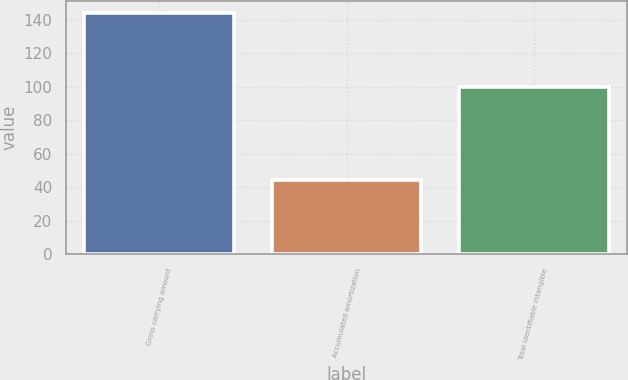<chart> <loc_0><loc_0><loc_500><loc_500><bar_chart><fcel>Gross carrying amount<fcel>Accumulated amortization<fcel>Total identifiable intangible<nl><fcel>144.1<fcel>44<fcel>100.1<nl></chart> 